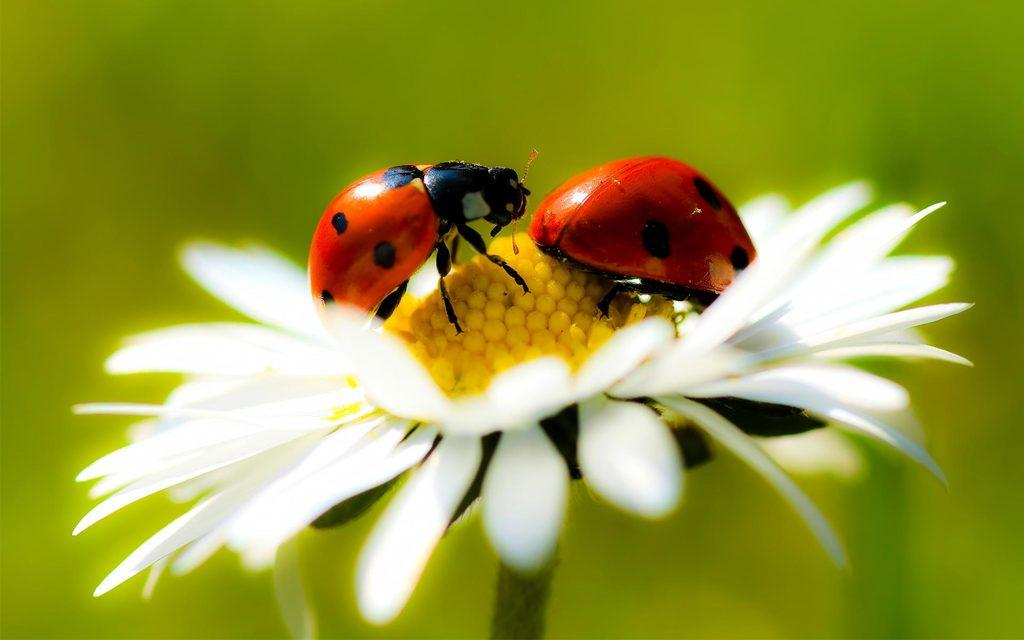What is the main subject of the image? There is a flower in the image. Are there any other living organisms present on the flower? Yes, there are two insects on the flower. How would you describe the background of the image? The background of the image is blurred. What type of chalk is being used to draw on the leather in the image? There is no chalk or leather present in the image; it only features a flower and two insects. 